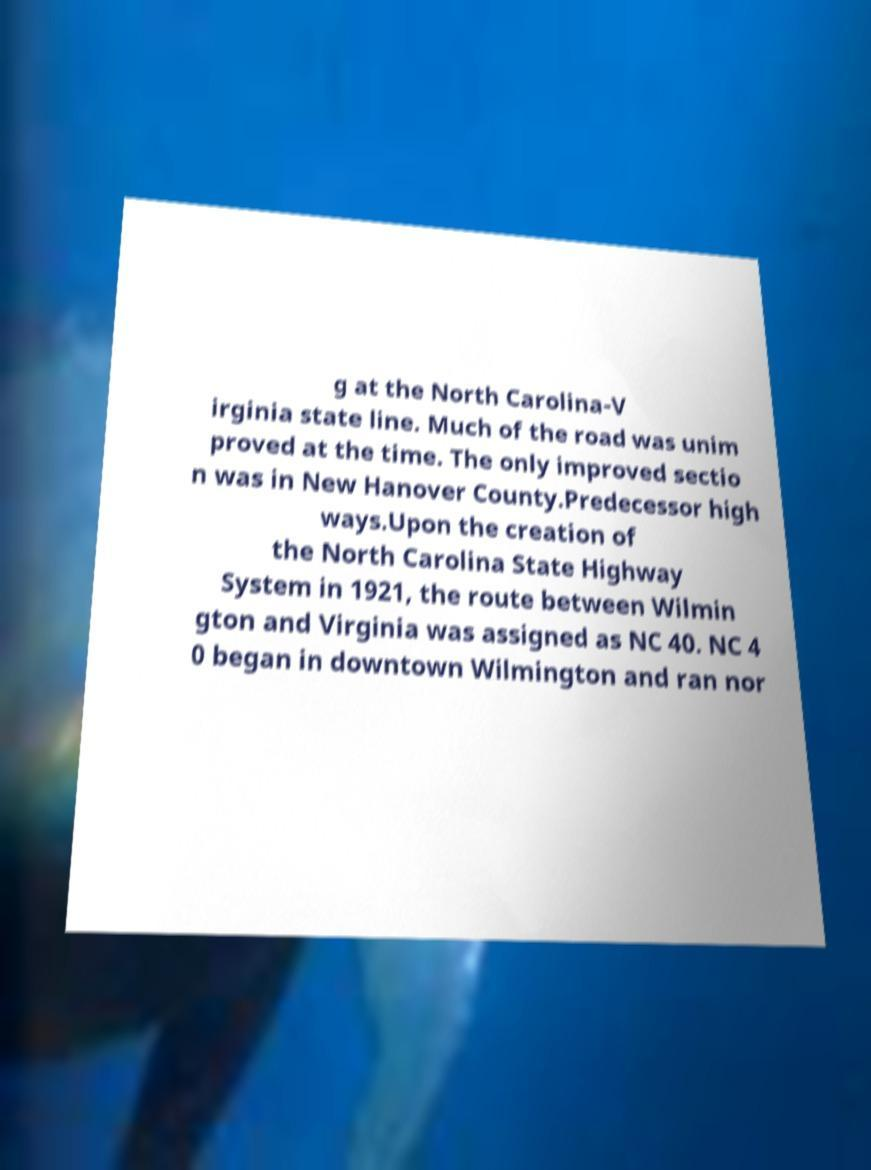For documentation purposes, I need the text within this image transcribed. Could you provide that? g at the North Carolina-V irginia state line. Much of the road was unim proved at the time. The only improved sectio n was in New Hanover County.Predecessor high ways.Upon the creation of the North Carolina State Highway System in 1921, the route between Wilmin gton and Virginia was assigned as NC 40. NC 4 0 began in downtown Wilmington and ran nor 